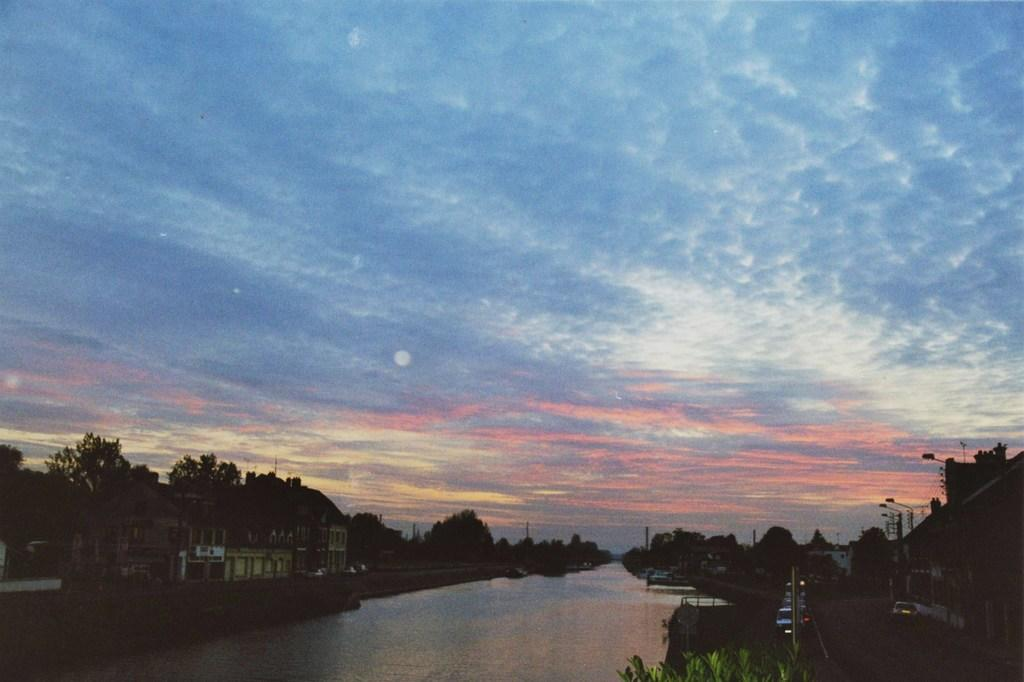What types of man-made structures can be seen in the image? There are vehicles, buildings, and light poles in the image. What natural elements are present in the image? There are trees and clouds in the image. What is visible in the background of the image? The sky is visible in the background of the image. Can you describe the objects in the image? There are some objects in the image, but their specific nature is not mentioned in the provided facts. What route are the vehicles taking in the image? The provided facts do not mention any specific route or direction for the vehicles. What purpose do the trees serve in the image? The provided facts do not mention any specific purpose for the trees; they are simply present in the image as a natural element. 